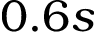<formula> <loc_0><loc_0><loc_500><loc_500>0 . 6 s</formula> 